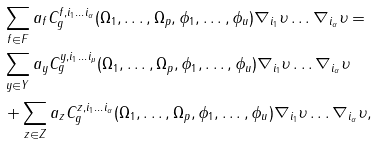<formula> <loc_0><loc_0><loc_500><loc_500>& \sum _ { f \in F } a _ { f } C ^ { f , i _ { 1 } \dots i _ { \alpha } } _ { g } ( \Omega _ { 1 } , \dots , \Omega _ { p } , \phi _ { 1 } , \dots , \phi _ { u } ) \nabla _ { i _ { 1 } } \upsilon \dots \nabla _ { i _ { \alpha } } \upsilon = \\ & \sum _ { y \in Y } a _ { y } C ^ { y , i _ { 1 } \dots i _ { \mu } } _ { g } ( \Omega _ { 1 } , \dots , \Omega _ { p } , \phi _ { 1 } , \dots , \phi _ { u } ) \nabla _ { i _ { 1 } } \upsilon \dots \nabla _ { i _ { \alpha } } \upsilon \\ & + \sum _ { z \in Z } a _ { z } C ^ { z , i _ { 1 } \dots i _ { \alpha } } _ { g } ( \Omega _ { 1 } , \dots , \Omega _ { p } , \phi _ { 1 } , \dots , \phi _ { u } ) \nabla _ { i _ { 1 } } \upsilon \dots \nabla _ { i _ { \alpha } } \upsilon ,</formula> 